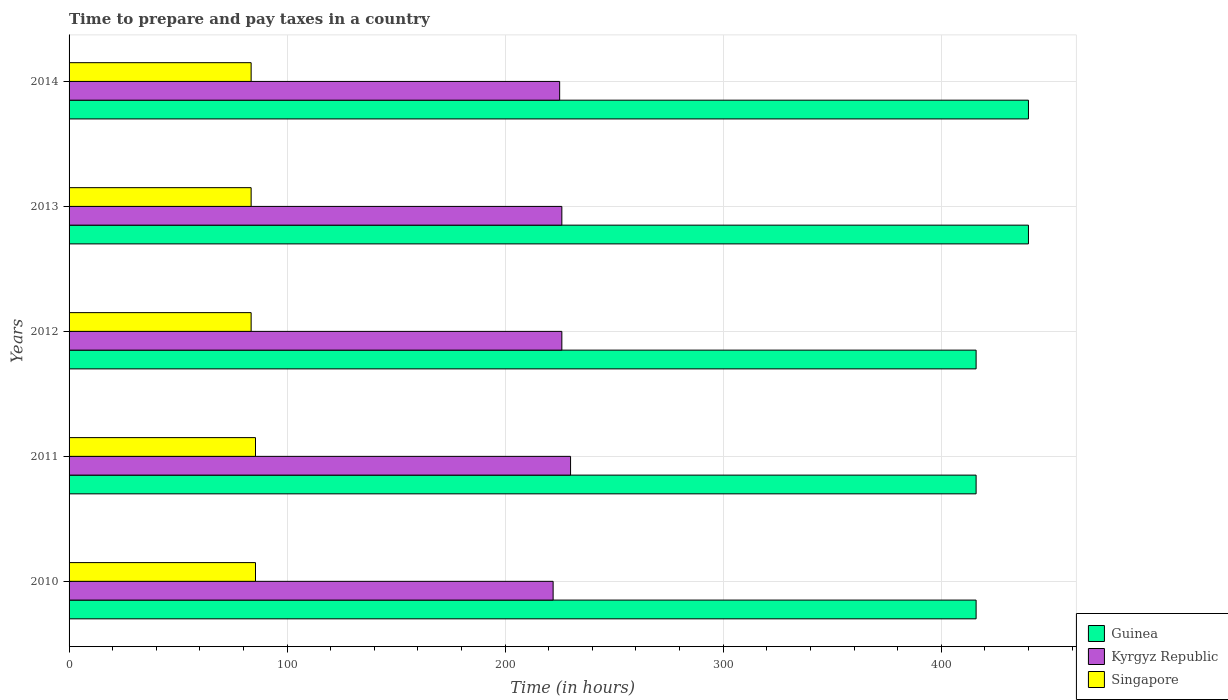Are the number of bars per tick equal to the number of legend labels?
Offer a very short reply. Yes. Are the number of bars on each tick of the Y-axis equal?
Provide a succinct answer. Yes. How many bars are there on the 2nd tick from the top?
Give a very brief answer. 3. How many bars are there on the 1st tick from the bottom?
Your answer should be very brief. 3. In how many cases, is the number of bars for a given year not equal to the number of legend labels?
Offer a terse response. 0. What is the number of hours required to prepare and pay taxes in Guinea in 2010?
Ensure brevity in your answer.  416. Across all years, what is the maximum number of hours required to prepare and pay taxes in Guinea?
Ensure brevity in your answer.  440. Across all years, what is the minimum number of hours required to prepare and pay taxes in Singapore?
Your response must be concise. 83.5. What is the total number of hours required to prepare and pay taxes in Kyrgyz Republic in the graph?
Give a very brief answer. 1129. What is the difference between the number of hours required to prepare and pay taxes in Kyrgyz Republic in 2010 and that in 2011?
Provide a succinct answer. -8. What is the difference between the number of hours required to prepare and pay taxes in Guinea in 2011 and the number of hours required to prepare and pay taxes in Singapore in 2014?
Ensure brevity in your answer.  332.5. What is the average number of hours required to prepare and pay taxes in Singapore per year?
Your answer should be very brief. 84.3. In the year 2010, what is the difference between the number of hours required to prepare and pay taxes in Kyrgyz Republic and number of hours required to prepare and pay taxes in Guinea?
Offer a terse response. -194. In how many years, is the number of hours required to prepare and pay taxes in Kyrgyz Republic greater than 420 hours?
Your answer should be compact. 0. What is the ratio of the number of hours required to prepare and pay taxes in Singapore in 2010 to that in 2013?
Make the answer very short. 1.02. What is the difference between the highest and the second highest number of hours required to prepare and pay taxes in Kyrgyz Republic?
Make the answer very short. 4. What is the difference between the highest and the lowest number of hours required to prepare and pay taxes in Kyrgyz Republic?
Ensure brevity in your answer.  8. Is the sum of the number of hours required to prepare and pay taxes in Guinea in 2012 and 2013 greater than the maximum number of hours required to prepare and pay taxes in Singapore across all years?
Ensure brevity in your answer.  Yes. What does the 1st bar from the top in 2011 represents?
Your answer should be compact. Singapore. What does the 1st bar from the bottom in 2012 represents?
Provide a succinct answer. Guinea. How many bars are there?
Give a very brief answer. 15. Does the graph contain any zero values?
Ensure brevity in your answer.  No. Where does the legend appear in the graph?
Your answer should be compact. Bottom right. How are the legend labels stacked?
Offer a terse response. Vertical. What is the title of the graph?
Ensure brevity in your answer.  Time to prepare and pay taxes in a country. Does "Channel Islands" appear as one of the legend labels in the graph?
Offer a very short reply. No. What is the label or title of the X-axis?
Your answer should be compact. Time (in hours). What is the Time (in hours) in Guinea in 2010?
Ensure brevity in your answer.  416. What is the Time (in hours) of Kyrgyz Republic in 2010?
Give a very brief answer. 222. What is the Time (in hours) of Singapore in 2010?
Provide a succinct answer. 85.5. What is the Time (in hours) in Guinea in 2011?
Keep it short and to the point. 416. What is the Time (in hours) of Kyrgyz Republic in 2011?
Offer a terse response. 230. What is the Time (in hours) of Singapore in 2011?
Keep it short and to the point. 85.5. What is the Time (in hours) in Guinea in 2012?
Offer a very short reply. 416. What is the Time (in hours) in Kyrgyz Republic in 2012?
Your response must be concise. 226. What is the Time (in hours) in Singapore in 2012?
Give a very brief answer. 83.5. What is the Time (in hours) of Guinea in 2013?
Ensure brevity in your answer.  440. What is the Time (in hours) in Kyrgyz Republic in 2013?
Keep it short and to the point. 226. What is the Time (in hours) in Singapore in 2013?
Your answer should be compact. 83.5. What is the Time (in hours) of Guinea in 2014?
Ensure brevity in your answer.  440. What is the Time (in hours) of Kyrgyz Republic in 2014?
Your answer should be very brief. 225. What is the Time (in hours) in Singapore in 2014?
Your response must be concise. 83.5. Across all years, what is the maximum Time (in hours) of Guinea?
Keep it short and to the point. 440. Across all years, what is the maximum Time (in hours) in Kyrgyz Republic?
Your answer should be compact. 230. Across all years, what is the maximum Time (in hours) of Singapore?
Offer a very short reply. 85.5. Across all years, what is the minimum Time (in hours) in Guinea?
Provide a short and direct response. 416. Across all years, what is the minimum Time (in hours) in Kyrgyz Republic?
Give a very brief answer. 222. Across all years, what is the minimum Time (in hours) in Singapore?
Offer a very short reply. 83.5. What is the total Time (in hours) in Guinea in the graph?
Your response must be concise. 2128. What is the total Time (in hours) in Kyrgyz Republic in the graph?
Offer a very short reply. 1129. What is the total Time (in hours) in Singapore in the graph?
Provide a short and direct response. 421.5. What is the difference between the Time (in hours) in Kyrgyz Republic in 2010 and that in 2011?
Offer a very short reply. -8. What is the difference between the Time (in hours) in Guinea in 2010 and that in 2013?
Your answer should be compact. -24. What is the difference between the Time (in hours) in Singapore in 2010 and that in 2013?
Your response must be concise. 2. What is the difference between the Time (in hours) of Guinea in 2010 and that in 2014?
Your response must be concise. -24. What is the difference between the Time (in hours) in Guinea in 2011 and that in 2012?
Provide a succinct answer. 0. What is the difference between the Time (in hours) in Kyrgyz Republic in 2011 and that in 2012?
Offer a very short reply. 4. What is the difference between the Time (in hours) in Singapore in 2011 and that in 2012?
Your answer should be very brief. 2. What is the difference between the Time (in hours) of Kyrgyz Republic in 2011 and that in 2013?
Your answer should be very brief. 4. What is the difference between the Time (in hours) of Kyrgyz Republic in 2011 and that in 2014?
Provide a succinct answer. 5. What is the difference between the Time (in hours) of Guinea in 2012 and that in 2013?
Give a very brief answer. -24. What is the difference between the Time (in hours) of Guinea in 2013 and that in 2014?
Keep it short and to the point. 0. What is the difference between the Time (in hours) in Singapore in 2013 and that in 2014?
Provide a succinct answer. 0. What is the difference between the Time (in hours) of Guinea in 2010 and the Time (in hours) of Kyrgyz Republic in 2011?
Provide a succinct answer. 186. What is the difference between the Time (in hours) of Guinea in 2010 and the Time (in hours) of Singapore in 2011?
Give a very brief answer. 330.5. What is the difference between the Time (in hours) of Kyrgyz Republic in 2010 and the Time (in hours) of Singapore in 2011?
Offer a terse response. 136.5. What is the difference between the Time (in hours) in Guinea in 2010 and the Time (in hours) in Kyrgyz Republic in 2012?
Your answer should be very brief. 190. What is the difference between the Time (in hours) in Guinea in 2010 and the Time (in hours) in Singapore in 2012?
Provide a short and direct response. 332.5. What is the difference between the Time (in hours) of Kyrgyz Republic in 2010 and the Time (in hours) of Singapore in 2012?
Provide a succinct answer. 138.5. What is the difference between the Time (in hours) of Guinea in 2010 and the Time (in hours) of Kyrgyz Republic in 2013?
Offer a terse response. 190. What is the difference between the Time (in hours) in Guinea in 2010 and the Time (in hours) in Singapore in 2013?
Provide a short and direct response. 332.5. What is the difference between the Time (in hours) in Kyrgyz Republic in 2010 and the Time (in hours) in Singapore in 2013?
Provide a succinct answer. 138.5. What is the difference between the Time (in hours) in Guinea in 2010 and the Time (in hours) in Kyrgyz Republic in 2014?
Keep it short and to the point. 191. What is the difference between the Time (in hours) of Guinea in 2010 and the Time (in hours) of Singapore in 2014?
Make the answer very short. 332.5. What is the difference between the Time (in hours) in Kyrgyz Republic in 2010 and the Time (in hours) in Singapore in 2014?
Your answer should be compact. 138.5. What is the difference between the Time (in hours) in Guinea in 2011 and the Time (in hours) in Kyrgyz Republic in 2012?
Offer a terse response. 190. What is the difference between the Time (in hours) in Guinea in 2011 and the Time (in hours) in Singapore in 2012?
Provide a succinct answer. 332.5. What is the difference between the Time (in hours) in Kyrgyz Republic in 2011 and the Time (in hours) in Singapore in 2012?
Ensure brevity in your answer.  146.5. What is the difference between the Time (in hours) in Guinea in 2011 and the Time (in hours) in Kyrgyz Republic in 2013?
Your response must be concise. 190. What is the difference between the Time (in hours) in Guinea in 2011 and the Time (in hours) in Singapore in 2013?
Offer a very short reply. 332.5. What is the difference between the Time (in hours) in Kyrgyz Republic in 2011 and the Time (in hours) in Singapore in 2013?
Offer a very short reply. 146.5. What is the difference between the Time (in hours) of Guinea in 2011 and the Time (in hours) of Kyrgyz Republic in 2014?
Your answer should be compact. 191. What is the difference between the Time (in hours) of Guinea in 2011 and the Time (in hours) of Singapore in 2014?
Give a very brief answer. 332.5. What is the difference between the Time (in hours) in Kyrgyz Republic in 2011 and the Time (in hours) in Singapore in 2014?
Make the answer very short. 146.5. What is the difference between the Time (in hours) in Guinea in 2012 and the Time (in hours) in Kyrgyz Republic in 2013?
Provide a succinct answer. 190. What is the difference between the Time (in hours) in Guinea in 2012 and the Time (in hours) in Singapore in 2013?
Your answer should be compact. 332.5. What is the difference between the Time (in hours) in Kyrgyz Republic in 2012 and the Time (in hours) in Singapore in 2013?
Give a very brief answer. 142.5. What is the difference between the Time (in hours) in Guinea in 2012 and the Time (in hours) in Kyrgyz Republic in 2014?
Offer a very short reply. 191. What is the difference between the Time (in hours) of Guinea in 2012 and the Time (in hours) of Singapore in 2014?
Give a very brief answer. 332.5. What is the difference between the Time (in hours) of Kyrgyz Republic in 2012 and the Time (in hours) of Singapore in 2014?
Your response must be concise. 142.5. What is the difference between the Time (in hours) of Guinea in 2013 and the Time (in hours) of Kyrgyz Republic in 2014?
Ensure brevity in your answer.  215. What is the difference between the Time (in hours) in Guinea in 2013 and the Time (in hours) in Singapore in 2014?
Your response must be concise. 356.5. What is the difference between the Time (in hours) of Kyrgyz Republic in 2013 and the Time (in hours) of Singapore in 2014?
Make the answer very short. 142.5. What is the average Time (in hours) in Guinea per year?
Offer a very short reply. 425.6. What is the average Time (in hours) of Kyrgyz Republic per year?
Your response must be concise. 225.8. What is the average Time (in hours) in Singapore per year?
Offer a very short reply. 84.3. In the year 2010, what is the difference between the Time (in hours) of Guinea and Time (in hours) of Kyrgyz Republic?
Your response must be concise. 194. In the year 2010, what is the difference between the Time (in hours) of Guinea and Time (in hours) of Singapore?
Your answer should be compact. 330.5. In the year 2010, what is the difference between the Time (in hours) of Kyrgyz Republic and Time (in hours) of Singapore?
Ensure brevity in your answer.  136.5. In the year 2011, what is the difference between the Time (in hours) in Guinea and Time (in hours) in Kyrgyz Republic?
Provide a short and direct response. 186. In the year 2011, what is the difference between the Time (in hours) in Guinea and Time (in hours) in Singapore?
Your answer should be compact. 330.5. In the year 2011, what is the difference between the Time (in hours) in Kyrgyz Republic and Time (in hours) in Singapore?
Provide a succinct answer. 144.5. In the year 2012, what is the difference between the Time (in hours) of Guinea and Time (in hours) of Kyrgyz Republic?
Your answer should be very brief. 190. In the year 2012, what is the difference between the Time (in hours) of Guinea and Time (in hours) of Singapore?
Your answer should be very brief. 332.5. In the year 2012, what is the difference between the Time (in hours) in Kyrgyz Republic and Time (in hours) in Singapore?
Give a very brief answer. 142.5. In the year 2013, what is the difference between the Time (in hours) in Guinea and Time (in hours) in Kyrgyz Republic?
Your answer should be compact. 214. In the year 2013, what is the difference between the Time (in hours) of Guinea and Time (in hours) of Singapore?
Provide a short and direct response. 356.5. In the year 2013, what is the difference between the Time (in hours) in Kyrgyz Republic and Time (in hours) in Singapore?
Offer a very short reply. 142.5. In the year 2014, what is the difference between the Time (in hours) of Guinea and Time (in hours) of Kyrgyz Republic?
Ensure brevity in your answer.  215. In the year 2014, what is the difference between the Time (in hours) of Guinea and Time (in hours) of Singapore?
Provide a short and direct response. 356.5. In the year 2014, what is the difference between the Time (in hours) of Kyrgyz Republic and Time (in hours) of Singapore?
Offer a terse response. 141.5. What is the ratio of the Time (in hours) in Kyrgyz Republic in 2010 to that in 2011?
Give a very brief answer. 0.97. What is the ratio of the Time (in hours) of Guinea in 2010 to that in 2012?
Offer a very short reply. 1. What is the ratio of the Time (in hours) of Kyrgyz Republic in 2010 to that in 2012?
Ensure brevity in your answer.  0.98. What is the ratio of the Time (in hours) of Singapore in 2010 to that in 2012?
Your answer should be very brief. 1.02. What is the ratio of the Time (in hours) in Guinea in 2010 to that in 2013?
Provide a short and direct response. 0.95. What is the ratio of the Time (in hours) of Kyrgyz Republic in 2010 to that in 2013?
Keep it short and to the point. 0.98. What is the ratio of the Time (in hours) in Singapore in 2010 to that in 2013?
Offer a very short reply. 1.02. What is the ratio of the Time (in hours) in Guinea in 2010 to that in 2014?
Your answer should be very brief. 0.95. What is the ratio of the Time (in hours) in Kyrgyz Republic in 2010 to that in 2014?
Offer a very short reply. 0.99. What is the ratio of the Time (in hours) of Singapore in 2010 to that in 2014?
Your answer should be compact. 1.02. What is the ratio of the Time (in hours) of Guinea in 2011 to that in 2012?
Provide a succinct answer. 1. What is the ratio of the Time (in hours) of Kyrgyz Republic in 2011 to that in 2012?
Provide a succinct answer. 1.02. What is the ratio of the Time (in hours) in Singapore in 2011 to that in 2012?
Offer a terse response. 1.02. What is the ratio of the Time (in hours) in Guinea in 2011 to that in 2013?
Provide a short and direct response. 0.95. What is the ratio of the Time (in hours) of Kyrgyz Republic in 2011 to that in 2013?
Provide a succinct answer. 1.02. What is the ratio of the Time (in hours) in Guinea in 2011 to that in 2014?
Your answer should be very brief. 0.95. What is the ratio of the Time (in hours) of Kyrgyz Republic in 2011 to that in 2014?
Ensure brevity in your answer.  1.02. What is the ratio of the Time (in hours) of Guinea in 2012 to that in 2013?
Give a very brief answer. 0.95. What is the ratio of the Time (in hours) of Kyrgyz Republic in 2012 to that in 2013?
Make the answer very short. 1. What is the ratio of the Time (in hours) of Singapore in 2012 to that in 2013?
Your response must be concise. 1. What is the ratio of the Time (in hours) in Guinea in 2012 to that in 2014?
Keep it short and to the point. 0.95. What is the ratio of the Time (in hours) in Kyrgyz Republic in 2012 to that in 2014?
Your response must be concise. 1. What is the ratio of the Time (in hours) in Guinea in 2013 to that in 2014?
Make the answer very short. 1. What is the ratio of the Time (in hours) in Kyrgyz Republic in 2013 to that in 2014?
Keep it short and to the point. 1. What is the ratio of the Time (in hours) in Singapore in 2013 to that in 2014?
Ensure brevity in your answer.  1. What is the difference between the highest and the second highest Time (in hours) of Kyrgyz Republic?
Your response must be concise. 4. What is the difference between the highest and the second highest Time (in hours) in Singapore?
Offer a terse response. 0. What is the difference between the highest and the lowest Time (in hours) in Guinea?
Offer a very short reply. 24. 